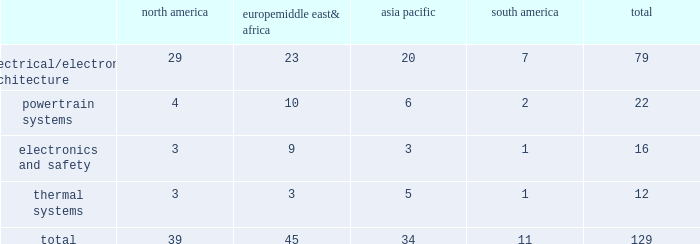Item 2 .
Properties as of december 31 , 2014 , we owned or leased 129 major manufacturing sites and 15 major technical centers in 33 countries .
A manufacturing site may include multiple plants and may be wholly or partially owned or leased .
We also have many smaller manufacturing sites , sales offices , warehouses , engineering centers , joint ventures and other investments strategically located throughout the world .
The table shows the regional distribution of our major manufacturing sites by the operating segment that uses such facilities : north america europe , middle east & africa asia pacific south america total .
In addition to these manufacturing sites , we had 15 major technical centers : five in north america ; five in europe , middle east and africa ; four in asia pacific ; and one in south america .
Of our 129 major manufacturing sites and 15 major technical centers , which include facilities owned or leased by our consolidated subsidiaries , 83 are primarily owned and 61 are primarily leased .
We frequently review our real estate portfolio and develop footprint strategies to support our customers 2019 global plans , while at the same time supporting our technical needs and controlling operating expenses .
We believe our evolving portfolio will meet current and anticipated future needs .
Item 3 .
Legal proceedings we are from time to time subject to various actions , claims , suits , government investigations , and other proceedings incidental to our business , including those arising out of alleged defects , breach of contracts , competition and antitrust matters , product warranties , intellectual property matters , personal injury claims and employment-related matters .
It is our opinion that the outcome of such matters will not have a material adverse impact on our consolidated financial position , results of operations , or cash flows .
With respect to warranty matters , although we cannot ensure that the future costs of warranty claims by customers will not be material , we believe our established reserves are adequate to cover potential warranty settlements .
However , the final amounts required to resolve these matters could differ materially from our recorded estimates .
Gm ignition switch recall in the first quarter of 2014 , gm , delphi 2019s largest customer , initiated a product recall related to ignition switches .
Delphi has received requests for information from , and is cooperating with , various government agencies related to this ignition switch recall .
In addition , delphi has been named as a co-defendant along with gm ( and in certain cases other parties ) in product liability and class action lawsuits related to this matter .
During the second quarter of 2014 , all of the class action cases were transferred to the united states district court for the southern district of new york ( the 201cdistrict court 201d ) for coordinated pretrial proceedings .
Two consolidated amended class action complaints were filed in the district court on october 14 , 2014 .
Delphi was not named as a defendant in either complaint .
Delphi believes the allegations contained in the product liability cases are without merit , and intends to vigorously defend against them .
Although no assurances can be made as to the ultimate outcome of these or any other future claims , delphi does not believe a loss is probable and , accordingly , no reserve has been made as of december 31 , 2014 .
Unsecured creditors litigation under the terms of the fourth amended and restated limited liability partnership agreement of delphi automotive llp ( the 201cfourth llp agreement 201d ) , if cumulative distributions to the members of delphi automotive llp under certain provisions of the fourth llp agreement exceed $ 7.2 billion , delphi , as disbursing agent on behalf of dphh , is required to pay to the holders of allowed general unsecured claims against old delphi , $ 32.50 for every $ 67.50 in excess of $ 7.2 billion distributed to the members , up to a maximum amount of $ 300 million .
In december 2014 , a complaint was filed in the bankruptcy court alleging that the redemption by delphi automotive llp of the membership interests of gm and the pbgc , and the repurchase of shares and payment of dividends by delphi automotive plc , constituted distributions under the terms of the fourth llp agreement approximating $ 7.2 billion .
Delphi considers cumulative distributions through december 31 , 2014 to be substantially below the $ 7.2 billion threshold , and intends to vigorously contest the allegations set forth in the complaint .
Accordingly , no accrual for this matter has been recorded as of december 31 , 2014. .
What is the percentage of europemiddle east& africa's sites concerning all electrical/electronic architecture sites? 
Rationale: it is the number of sites in europemiddle east& africa divided by the total sites of electrical/electronic architecture , then turned into a percentage .
Computations: (23 / 79)
Answer: 0.29114. 